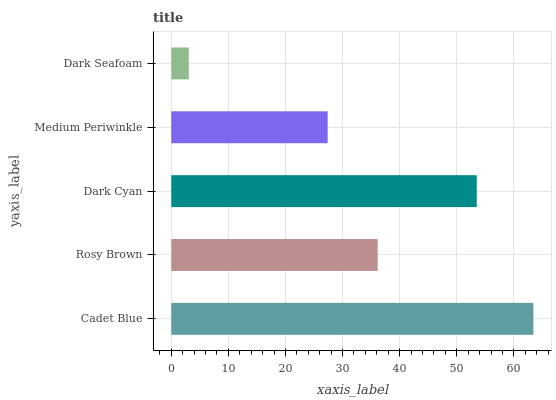Is Dark Seafoam the minimum?
Answer yes or no. Yes. Is Cadet Blue the maximum?
Answer yes or no. Yes. Is Rosy Brown the minimum?
Answer yes or no. No. Is Rosy Brown the maximum?
Answer yes or no. No. Is Cadet Blue greater than Rosy Brown?
Answer yes or no. Yes. Is Rosy Brown less than Cadet Blue?
Answer yes or no. Yes. Is Rosy Brown greater than Cadet Blue?
Answer yes or no. No. Is Cadet Blue less than Rosy Brown?
Answer yes or no. No. Is Rosy Brown the high median?
Answer yes or no. Yes. Is Rosy Brown the low median?
Answer yes or no. Yes. Is Cadet Blue the high median?
Answer yes or no. No. Is Medium Periwinkle the low median?
Answer yes or no. No. 